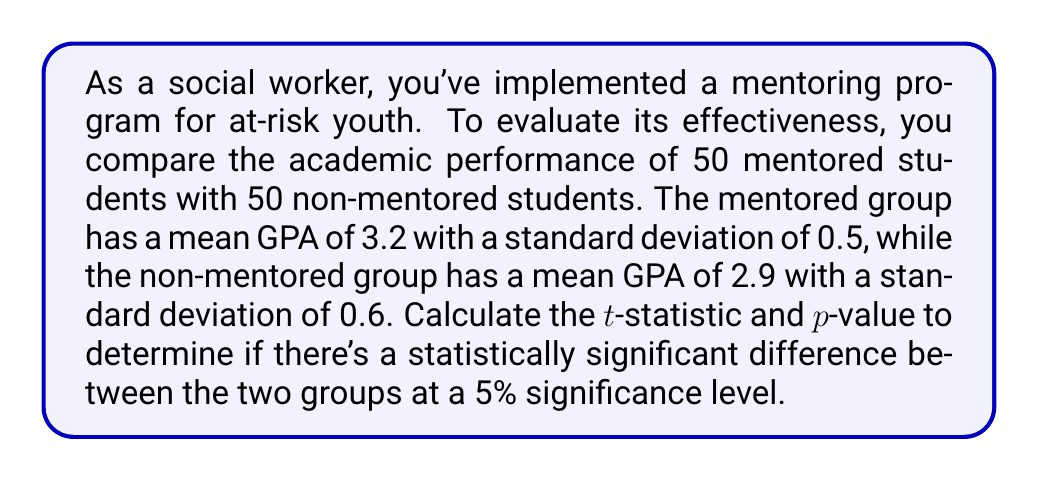Provide a solution to this math problem. To determine statistical significance, we'll use an independent samples t-test.

Step 1: Calculate the pooled standard deviation.
$$s_p = \sqrt{\frac{(n_1 - 1)s_1^2 + (n_2 - 1)s_2^2}{n_1 + n_2 - 2}}$$
Where $n_1 = n_2 = 50$, $s_1 = 0.5$, and $s_2 = 0.6$

$$s_p = \sqrt{\frac{(50 - 1)(0.5)^2 + (50 - 1)(0.6)^2}{50 + 50 - 2}} = \sqrt{\frac{12.25 + 17.64}{98}} = 0.5527$$

Step 2: Calculate the t-statistic.
$$t = \frac{\bar{x}_1 - \bar{x}_2}{s_p\sqrt{\frac{2}{n}}}$$
Where $\bar{x}_1 = 3.2$ and $\bar{x}_2 = 2.9$

$$t = \frac{3.2 - 2.9}{0.5527\sqrt{\frac{2}{50}}} = 2.9615$$

Step 3: Calculate degrees of freedom.
$df = n_1 + n_2 - 2 = 50 + 50 - 2 = 98$

Step 4: Determine the critical t-value for a two-tailed test at 5% significance level.
For $df = 98$ and $\alpha = 0.05$, the critical t-value is approximately 1.9845.

Step 5: Compare the calculated t-statistic to the critical t-value.
Since $2.9615 > 1.9845$, we reject the null hypothesis.

Step 6: Calculate the p-value using a t-distribution calculator or table.
The p-value for $t = 2.9615$ and $df = 98$ is approximately 0.0038.
Answer: t-statistic: 2.9615, p-value: 0.0038 